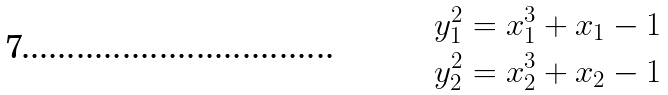Convert formula to latex. <formula><loc_0><loc_0><loc_500><loc_500>y _ { 1 } ^ { 2 } = x _ { 1 } ^ { 3 } + x _ { 1 } - 1 \\ y _ { 2 } ^ { 2 } = x _ { 2 } ^ { 3 } + x _ { 2 } - 1</formula> 